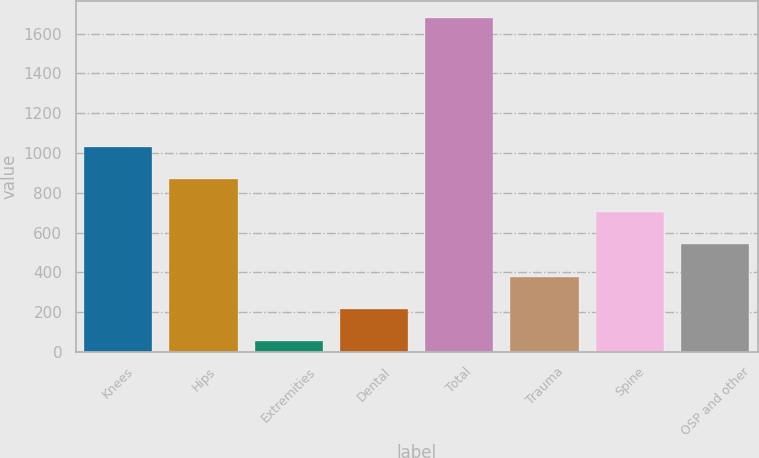Convert chart to OTSL. <chart><loc_0><loc_0><loc_500><loc_500><bar_chart><fcel>Knees<fcel>Hips<fcel>Extremities<fcel>Dental<fcel>Total<fcel>Trauma<fcel>Spine<fcel>OSP and other<nl><fcel>1029.56<fcel>867<fcel>54.2<fcel>216.76<fcel>1679.8<fcel>379.32<fcel>704.44<fcel>541.88<nl></chart> 